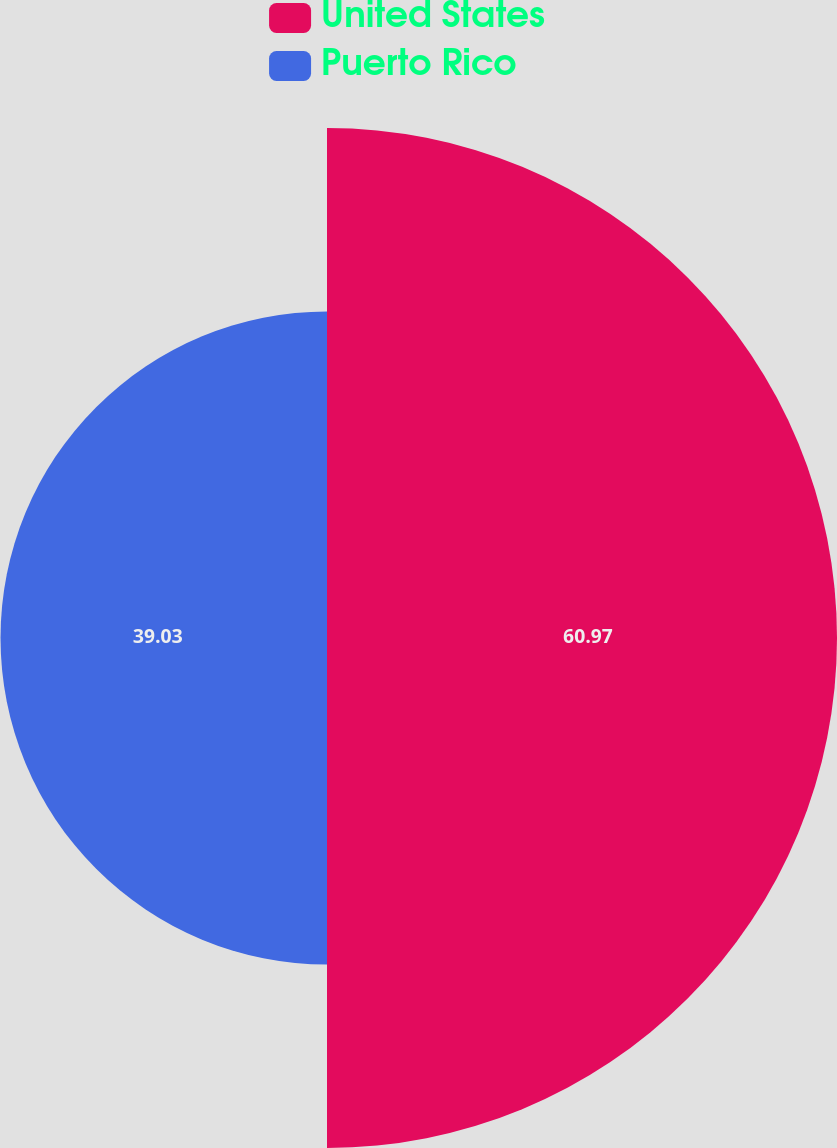<chart> <loc_0><loc_0><loc_500><loc_500><pie_chart><fcel>United States<fcel>Puerto Rico<nl><fcel>60.97%<fcel>39.03%<nl></chart> 